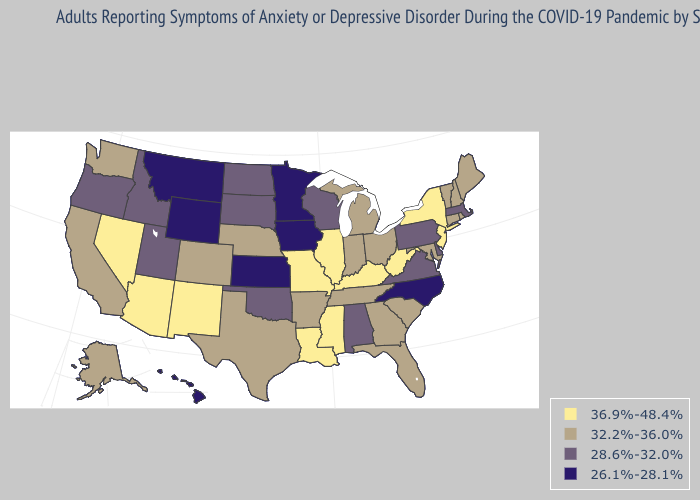What is the value of Oklahoma?
Short answer required. 28.6%-32.0%. Name the states that have a value in the range 36.9%-48.4%?
Write a very short answer. Arizona, Illinois, Kentucky, Louisiana, Mississippi, Missouri, Nevada, New Jersey, New Mexico, New York, West Virginia. Name the states that have a value in the range 32.2%-36.0%?
Write a very short answer. Alaska, Arkansas, California, Colorado, Connecticut, Florida, Georgia, Indiana, Maine, Maryland, Michigan, Nebraska, New Hampshire, Ohio, Rhode Island, South Carolina, Tennessee, Texas, Vermont, Washington. Name the states that have a value in the range 28.6%-32.0%?
Keep it brief. Alabama, Delaware, Idaho, Massachusetts, North Dakota, Oklahoma, Oregon, Pennsylvania, South Dakota, Utah, Virginia, Wisconsin. Among the states that border Pennsylvania , which have the lowest value?
Quick response, please. Delaware. Which states have the highest value in the USA?
Concise answer only. Arizona, Illinois, Kentucky, Louisiana, Mississippi, Missouri, Nevada, New Jersey, New Mexico, New York, West Virginia. What is the highest value in states that border Texas?
Quick response, please. 36.9%-48.4%. What is the value of Maine?
Short answer required. 32.2%-36.0%. What is the value of Maine?
Quick response, please. 32.2%-36.0%. What is the value of Montana?
Quick response, please. 26.1%-28.1%. Name the states that have a value in the range 32.2%-36.0%?
Short answer required. Alaska, Arkansas, California, Colorado, Connecticut, Florida, Georgia, Indiana, Maine, Maryland, Michigan, Nebraska, New Hampshire, Ohio, Rhode Island, South Carolina, Tennessee, Texas, Vermont, Washington. Does Utah have a lower value than Iowa?
Concise answer only. No. Which states have the lowest value in the South?
Write a very short answer. North Carolina. Among the states that border Oklahoma , which have the highest value?
Keep it brief. Missouri, New Mexico. Among the states that border Michigan , which have the highest value?
Short answer required. Indiana, Ohio. 